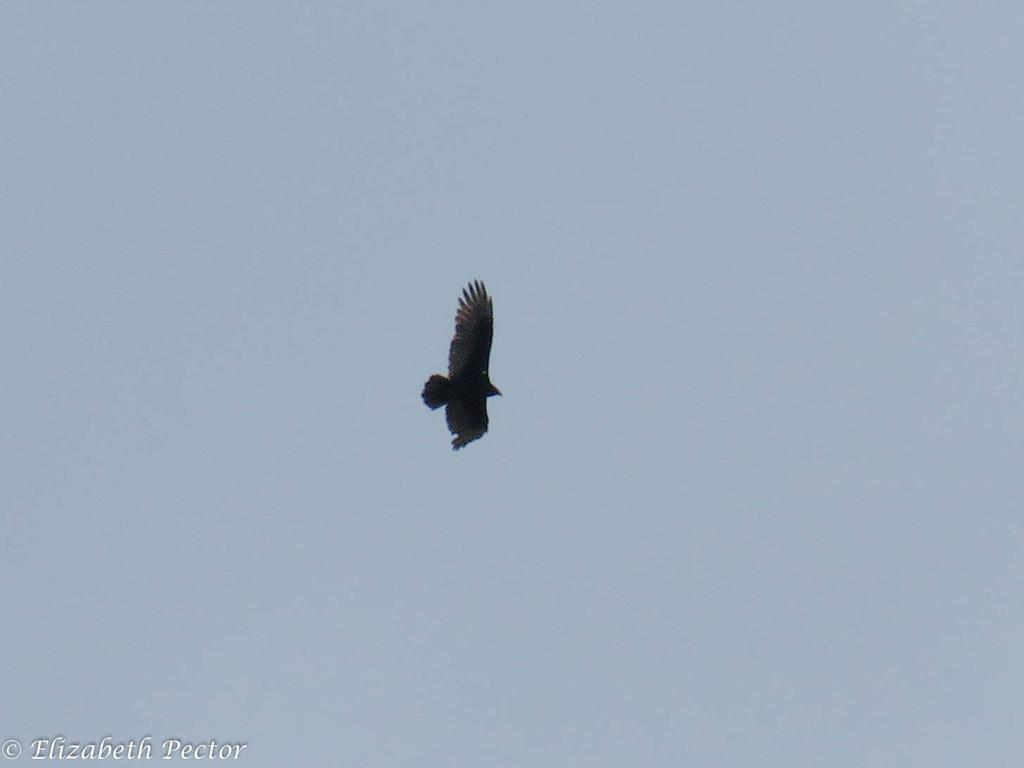What type of animal is in the image? There is a black color bird in the image. Where is the bird located in the image? The bird is in the air. What can be seen in the background of the image? The sky is visible in the background of the image. Is there any text or marking in the image? Yes, there is a watermark in the left bottom side of the image. How many women are sitting on the boat in the image? There is no boat or women present in the image; it features a black color bird in the air. What type of furniture is visible in the image? There is no furniture present in the image. 